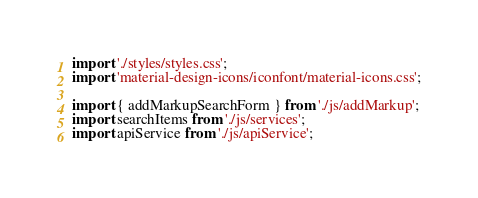<code> <loc_0><loc_0><loc_500><loc_500><_JavaScript_>import './styles/styles.css';
import 'material-design-icons/iconfont/material-icons.css';

import { addMarkupSearchForm } from './js/addMarkup';
import searchItems from './js/services';
import apiService from './js/apiService';</code> 